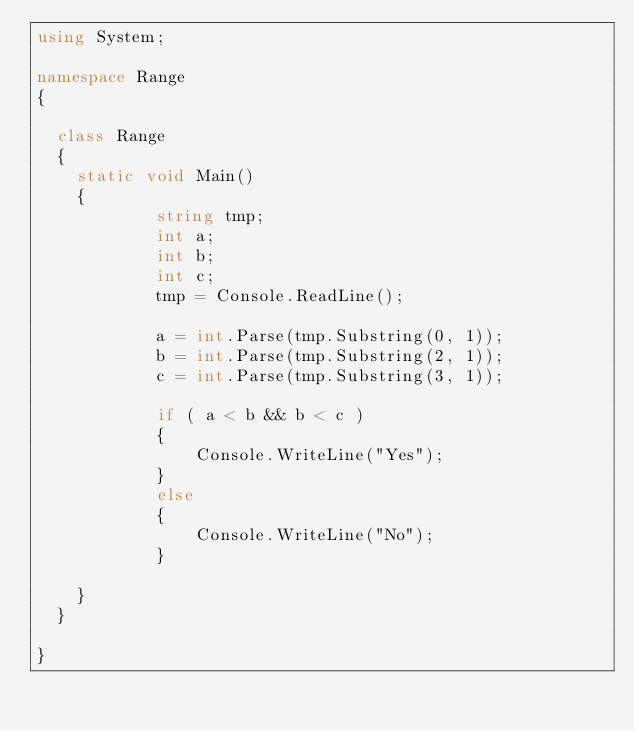Convert code to text. <code><loc_0><loc_0><loc_500><loc_500><_C#_>using System;

namespace Range
{

	class Range
	{
		static void Main()
		{
            string tmp;
            int a;
            int b;
            int c;
            tmp = Console.ReadLine();

            a = int.Parse(tmp.Substring(0, 1));
            b = int.Parse(tmp.Substring(2, 1));
            c = int.Parse(tmp.Substring(3, 1));
            
            if ( a < b && b < c )
            {
                Console.WriteLine("Yes");
            }
            else
            {
                Console.WriteLine("No");
            }

		}
	}

}</code> 